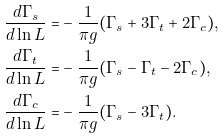<formula> <loc_0><loc_0><loc_500><loc_500>\frac { d \Gamma _ { s } } { d \ln L } = & - \frac { 1 } { \pi g } ( \Gamma _ { s } + 3 \Gamma _ { t } + 2 \Gamma _ { c } ) , \\ \frac { d \Gamma _ { t } } { d \ln L } = & - \frac { 1 } { \pi g } ( \Gamma _ { s } - \Gamma _ { t } - 2 \Gamma _ { c } ) , \\ \frac { d \Gamma _ { c } } { d \ln L } = & - \frac { 1 } { \pi g } ( \Gamma _ { s } - 3 \Gamma _ { t } ) .</formula> 